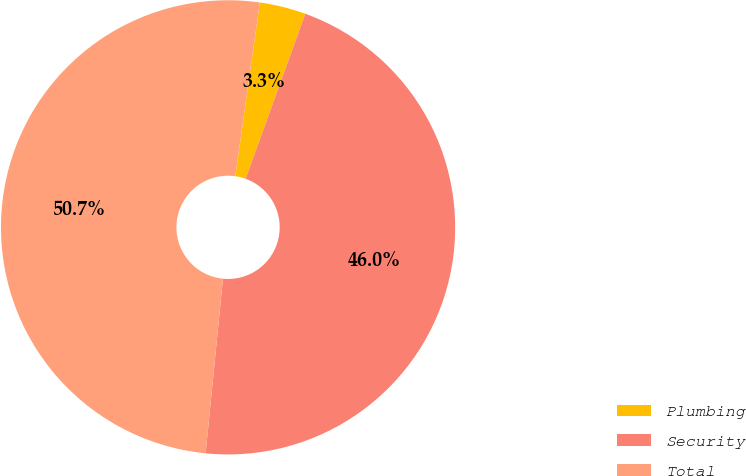Convert chart. <chart><loc_0><loc_0><loc_500><loc_500><pie_chart><fcel>Plumbing<fcel>Security<fcel>Total<nl><fcel>3.29%<fcel>46.05%<fcel>50.66%<nl></chart> 